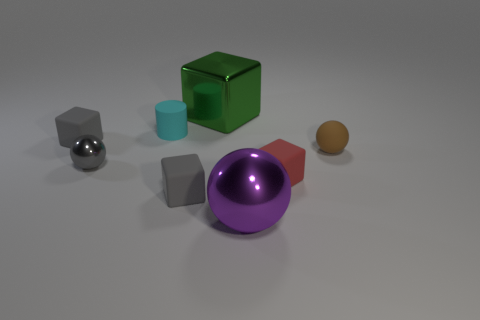Add 1 large green metal things. How many objects exist? 9 Subtract all cylinders. How many objects are left? 7 Add 2 brown rubber things. How many brown rubber things exist? 3 Subtract 0 blue balls. How many objects are left? 8 Subtract all tiny cyan cylinders. Subtract all red cubes. How many objects are left? 6 Add 1 small cyan rubber objects. How many small cyan rubber objects are left? 2 